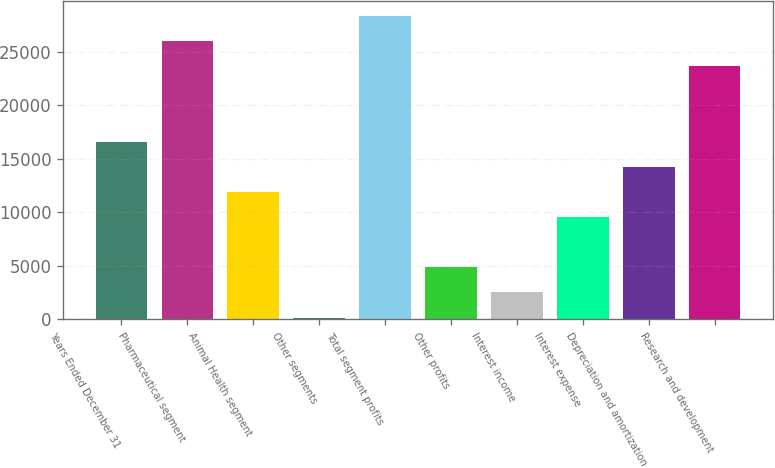Convert chart to OTSL. <chart><loc_0><loc_0><loc_500><loc_500><bar_chart><fcel>Years Ended December 31<fcel>Pharmaceutical segment<fcel>Animal Health segment<fcel>Other segments<fcel>Total segment profits<fcel>Other profits<fcel>Interest income<fcel>Interest expense<fcel>Depreciation and amortization<fcel>Research and development<nl><fcel>16594.6<fcel>25993.8<fcel>11895<fcel>146<fcel>28343.6<fcel>4845.6<fcel>2495.8<fcel>9545.2<fcel>14244.8<fcel>23644<nl></chart> 